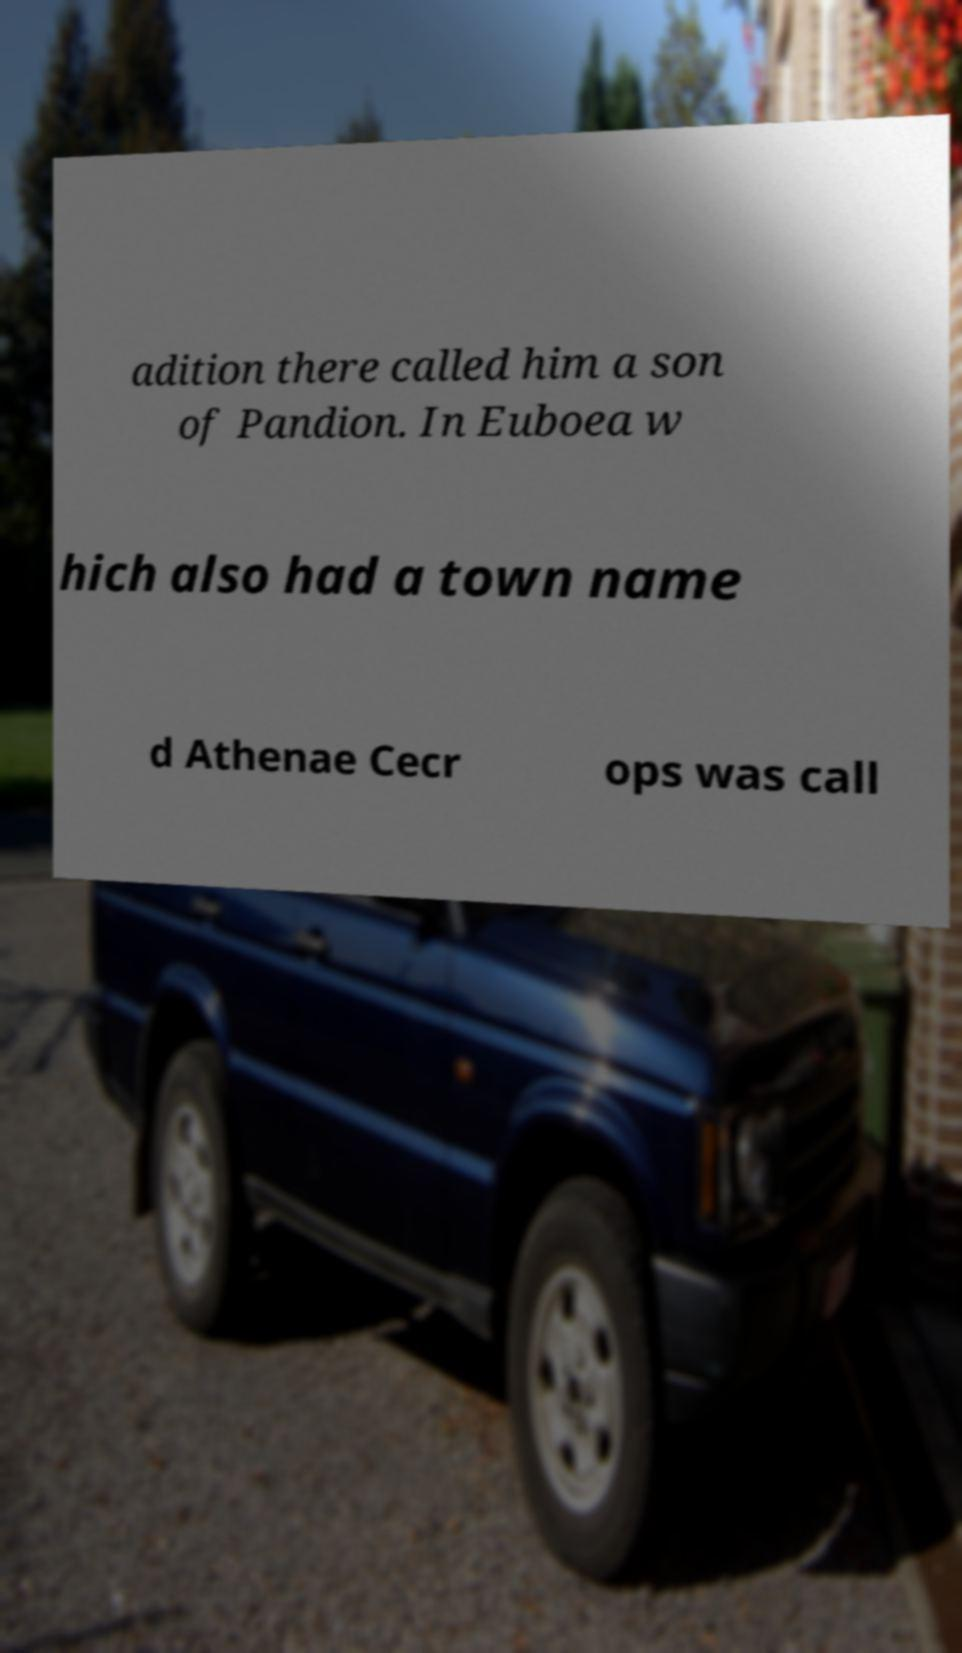For documentation purposes, I need the text within this image transcribed. Could you provide that? adition there called him a son of Pandion. In Euboea w hich also had a town name d Athenae Cecr ops was call 